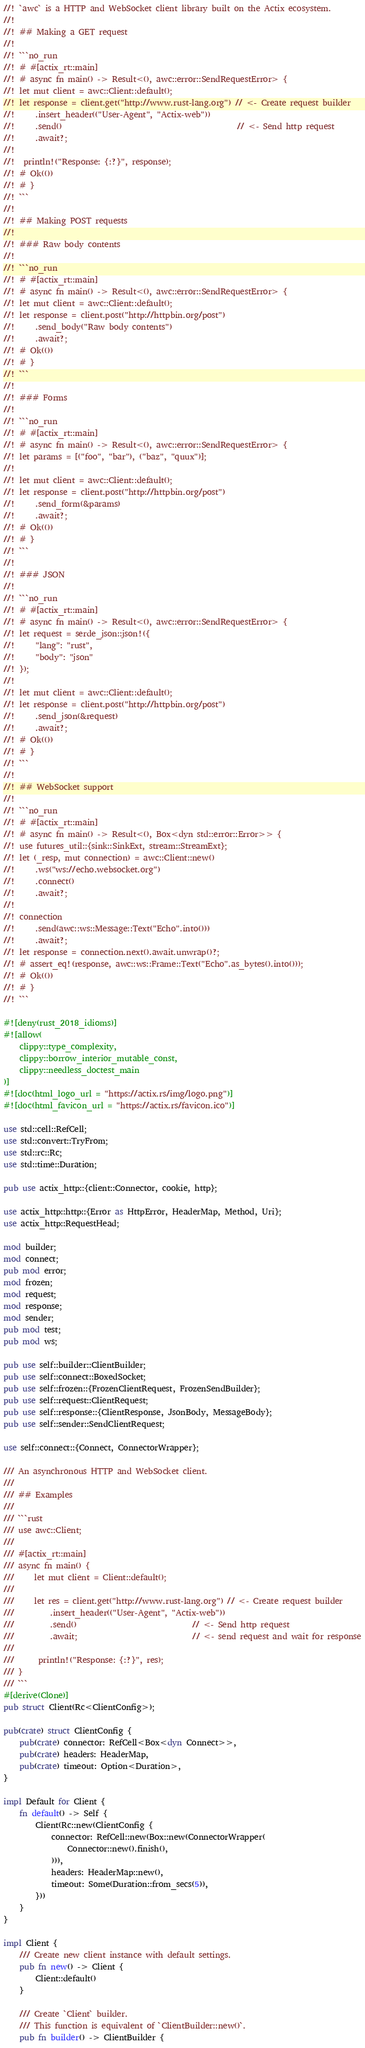<code> <loc_0><loc_0><loc_500><loc_500><_Rust_>//! `awc` is a HTTP and WebSocket client library built on the Actix ecosystem.
//!
//! ## Making a GET request
//!
//! ```no_run
//! # #[actix_rt::main]
//! # async fn main() -> Result<(), awc::error::SendRequestError> {
//! let mut client = awc::Client::default();
//! let response = client.get("http://www.rust-lang.org") // <- Create request builder
//!     .insert_header(("User-Agent", "Actix-web"))
//!     .send()                                            // <- Send http request
//!     .await?;
//!
//!  println!("Response: {:?}", response);
//! # Ok(())
//! # }
//! ```
//!
//! ## Making POST requests
//!
//! ### Raw body contents
//!
//! ```no_run
//! # #[actix_rt::main]
//! # async fn main() -> Result<(), awc::error::SendRequestError> {
//! let mut client = awc::Client::default();
//! let response = client.post("http://httpbin.org/post")
//!     .send_body("Raw body contents")
//!     .await?;
//! # Ok(())
//! # }
//! ```
//!
//! ### Forms
//!
//! ```no_run
//! # #[actix_rt::main]
//! # async fn main() -> Result<(), awc::error::SendRequestError> {
//! let params = [("foo", "bar"), ("baz", "quux")];
//!
//! let mut client = awc::Client::default();
//! let response = client.post("http://httpbin.org/post")
//!     .send_form(&params)
//!     .await?;
//! # Ok(())
//! # }
//! ```
//!
//! ### JSON
//!
//! ```no_run
//! # #[actix_rt::main]
//! # async fn main() -> Result<(), awc::error::SendRequestError> {
//! let request = serde_json::json!({
//!     "lang": "rust",
//!     "body": "json"
//! });
//!
//! let mut client = awc::Client::default();
//! let response = client.post("http://httpbin.org/post")
//!     .send_json(&request)
//!     .await?;
//! # Ok(())
//! # }
//! ```
//!
//! ## WebSocket support
//!
//! ```no_run
//! # #[actix_rt::main]
//! # async fn main() -> Result<(), Box<dyn std::error::Error>> {
//! use futures_util::{sink::SinkExt, stream::StreamExt};
//! let (_resp, mut connection) = awc::Client::new()
//!     .ws("ws://echo.websocket.org")
//!     .connect()
//!     .await?;
//!
//! connection
//!     .send(awc::ws::Message::Text("Echo".into()))
//!     .await?;
//! let response = connection.next().await.unwrap()?;
//! # assert_eq!(response, awc::ws::Frame::Text("Echo".as_bytes().into()));
//! # Ok(())
//! # }
//! ```

#![deny(rust_2018_idioms)]
#![allow(
    clippy::type_complexity,
    clippy::borrow_interior_mutable_const,
    clippy::needless_doctest_main
)]
#![doc(html_logo_url = "https://actix.rs/img/logo.png")]
#![doc(html_favicon_url = "https://actix.rs/favicon.ico")]

use std::cell::RefCell;
use std::convert::TryFrom;
use std::rc::Rc;
use std::time::Duration;

pub use actix_http::{client::Connector, cookie, http};

use actix_http::http::{Error as HttpError, HeaderMap, Method, Uri};
use actix_http::RequestHead;

mod builder;
mod connect;
pub mod error;
mod frozen;
mod request;
mod response;
mod sender;
pub mod test;
pub mod ws;

pub use self::builder::ClientBuilder;
pub use self::connect::BoxedSocket;
pub use self::frozen::{FrozenClientRequest, FrozenSendBuilder};
pub use self::request::ClientRequest;
pub use self::response::{ClientResponse, JsonBody, MessageBody};
pub use self::sender::SendClientRequest;

use self::connect::{Connect, ConnectorWrapper};

/// An asynchronous HTTP and WebSocket client.
///
/// ## Examples
///
/// ```rust
/// use awc::Client;
///
/// #[actix_rt::main]
/// async fn main() {
///     let mut client = Client::default();
///
///     let res = client.get("http://www.rust-lang.org") // <- Create request builder
///         .insert_header(("User-Agent", "Actix-web"))
///         .send()                             // <- Send http request
///         .await;                             // <- send request and wait for response
///
///      println!("Response: {:?}", res);
/// }
/// ```
#[derive(Clone)]
pub struct Client(Rc<ClientConfig>);

pub(crate) struct ClientConfig {
    pub(crate) connector: RefCell<Box<dyn Connect>>,
    pub(crate) headers: HeaderMap,
    pub(crate) timeout: Option<Duration>,
}

impl Default for Client {
    fn default() -> Self {
        Client(Rc::new(ClientConfig {
            connector: RefCell::new(Box::new(ConnectorWrapper(
                Connector::new().finish(),
            ))),
            headers: HeaderMap::new(),
            timeout: Some(Duration::from_secs(5)),
        }))
    }
}

impl Client {
    /// Create new client instance with default settings.
    pub fn new() -> Client {
        Client::default()
    }

    /// Create `Client` builder.
    /// This function is equivalent of `ClientBuilder::new()`.
    pub fn builder() -> ClientBuilder {</code> 